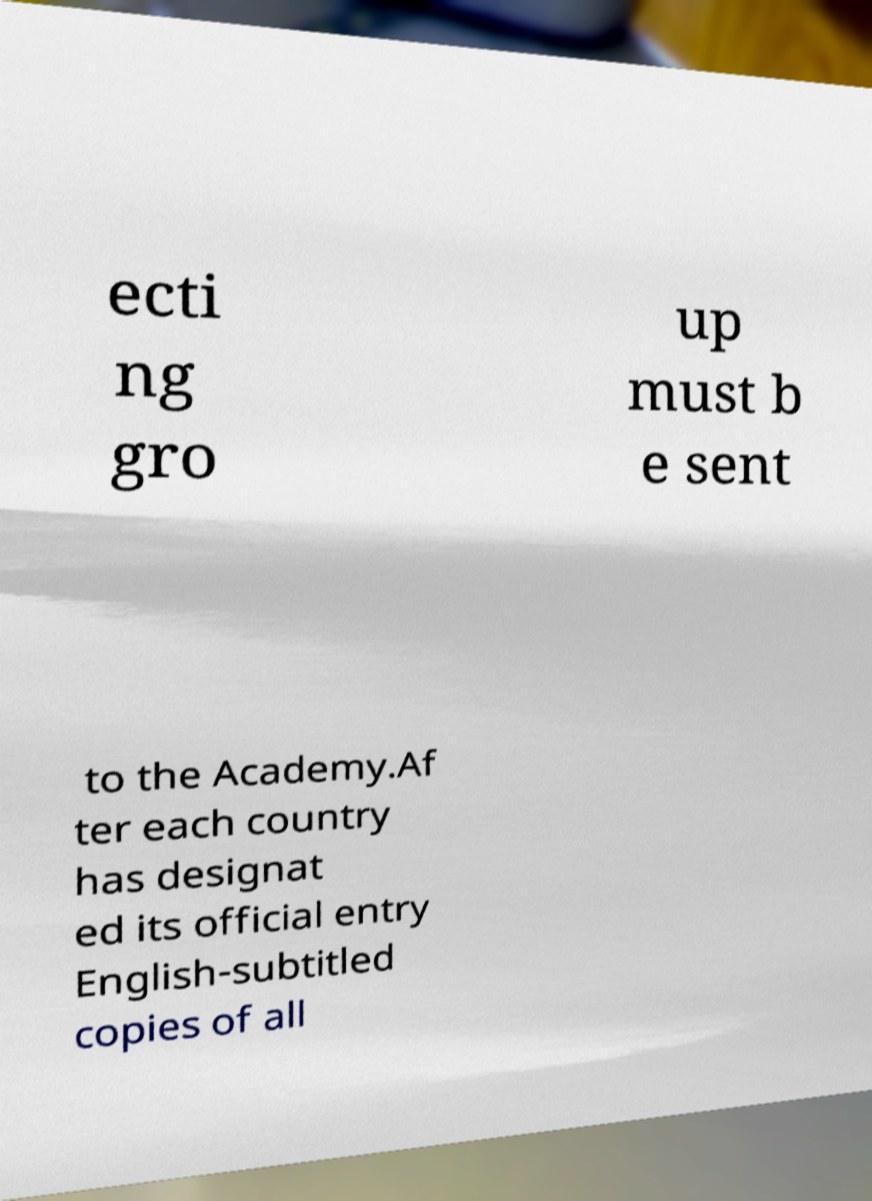There's text embedded in this image that I need extracted. Can you transcribe it verbatim? ecti ng gro up must b e sent to the Academy.Af ter each country has designat ed its official entry English-subtitled copies of all 